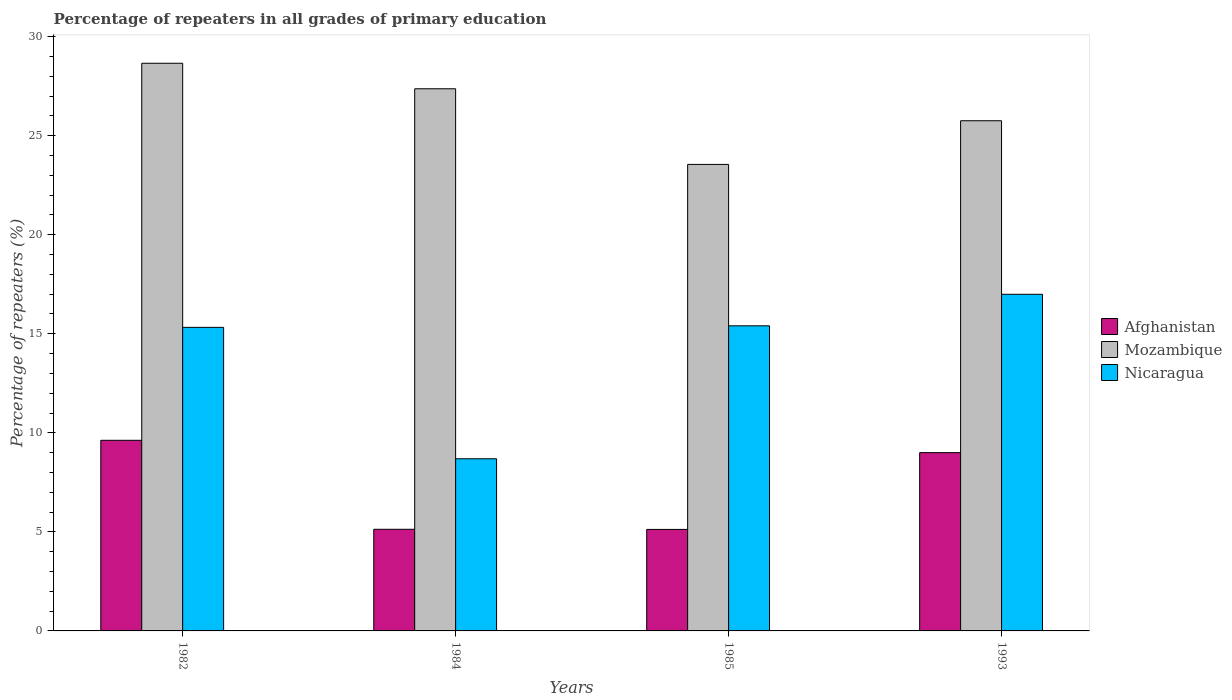How many groups of bars are there?
Keep it short and to the point. 4. Are the number of bars per tick equal to the number of legend labels?
Provide a short and direct response. Yes. How many bars are there on the 4th tick from the left?
Offer a very short reply. 3. How many bars are there on the 4th tick from the right?
Offer a terse response. 3. What is the label of the 2nd group of bars from the left?
Give a very brief answer. 1984. What is the percentage of repeaters in Nicaragua in 1993?
Make the answer very short. 16.99. Across all years, what is the maximum percentage of repeaters in Afghanistan?
Ensure brevity in your answer.  9.62. Across all years, what is the minimum percentage of repeaters in Nicaragua?
Offer a terse response. 8.69. In which year was the percentage of repeaters in Mozambique maximum?
Give a very brief answer. 1982. In which year was the percentage of repeaters in Afghanistan minimum?
Provide a succinct answer. 1985. What is the total percentage of repeaters in Nicaragua in the graph?
Offer a very short reply. 56.41. What is the difference between the percentage of repeaters in Afghanistan in 1984 and that in 1985?
Make the answer very short. 0.01. What is the difference between the percentage of repeaters in Mozambique in 1985 and the percentage of repeaters in Afghanistan in 1984?
Your response must be concise. 18.42. What is the average percentage of repeaters in Mozambique per year?
Your response must be concise. 26.33. In the year 1985, what is the difference between the percentage of repeaters in Nicaragua and percentage of repeaters in Afghanistan?
Offer a very short reply. 10.28. What is the ratio of the percentage of repeaters in Mozambique in 1982 to that in 1984?
Offer a terse response. 1.05. Is the percentage of repeaters in Mozambique in 1982 less than that in 1984?
Your answer should be very brief. No. What is the difference between the highest and the second highest percentage of repeaters in Nicaragua?
Provide a succinct answer. 1.59. What is the difference between the highest and the lowest percentage of repeaters in Mozambique?
Keep it short and to the point. 5.11. In how many years, is the percentage of repeaters in Afghanistan greater than the average percentage of repeaters in Afghanistan taken over all years?
Provide a short and direct response. 2. Is the sum of the percentage of repeaters in Afghanistan in 1985 and 1993 greater than the maximum percentage of repeaters in Mozambique across all years?
Your answer should be very brief. No. What does the 2nd bar from the left in 1993 represents?
Offer a very short reply. Mozambique. What does the 2nd bar from the right in 1993 represents?
Provide a short and direct response. Mozambique. Is it the case that in every year, the sum of the percentage of repeaters in Nicaragua and percentage of repeaters in Afghanistan is greater than the percentage of repeaters in Mozambique?
Offer a terse response. No. How many bars are there?
Give a very brief answer. 12. Are all the bars in the graph horizontal?
Make the answer very short. No. How many years are there in the graph?
Offer a very short reply. 4. What is the difference between two consecutive major ticks on the Y-axis?
Your answer should be very brief. 5. Are the values on the major ticks of Y-axis written in scientific E-notation?
Your response must be concise. No. Does the graph contain any zero values?
Offer a terse response. No. Where does the legend appear in the graph?
Your response must be concise. Center right. How many legend labels are there?
Your answer should be very brief. 3. What is the title of the graph?
Your response must be concise. Percentage of repeaters in all grades of primary education. What is the label or title of the X-axis?
Ensure brevity in your answer.  Years. What is the label or title of the Y-axis?
Offer a very short reply. Percentage of repeaters (%). What is the Percentage of repeaters (%) of Afghanistan in 1982?
Offer a terse response. 9.62. What is the Percentage of repeaters (%) in Mozambique in 1982?
Your response must be concise. 28.65. What is the Percentage of repeaters (%) in Nicaragua in 1982?
Ensure brevity in your answer.  15.32. What is the Percentage of repeaters (%) of Afghanistan in 1984?
Provide a short and direct response. 5.13. What is the Percentage of repeaters (%) of Mozambique in 1984?
Make the answer very short. 27.37. What is the Percentage of repeaters (%) in Nicaragua in 1984?
Keep it short and to the point. 8.69. What is the Percentage of repeaters (%) in Afghanistan in 1985?
Your response must be concise. 5.12. What is the Percentage of repeaters (%) in Mozambique in 1985?
Make the answer very short. 23.55. What is the Percentage of repeaters (%) of Nicaragua in 1985?
Offer a very short reply. 15.4. What is the Percentage of repeaters (%) of Afghanistan in 1993?
Offer a terse response. 9. What is the Percentage of repeaters (%) of Mozambique in 1993?
Offer a very short reply. 25.75. What is the Percentage of repeaters (%) in Nicaragua in 1993?
Offer a terse response. 16.99. Across all years, what is the maximum Percentage of repeaters (%) in Afghanistan?
Keep it short and to the point. 9.62. Across all years, what is the maximum Percentage of repeaters (%) in Mozambique?
Your answer should be compact. 28.65. Across all years, what is the maximum Percentage of repeaters (%) of Nicaragua?
Provide a short and direct response. 16.99. Across all years, what is the minimum Percentage of repeaters (%) of Afghanistan?
Your answer should be very brief. 5.12. Across all years, what is the minimum Percentage of repeaters (%) of Mozambique?
Your response must be concise. 23.55. Across all years, what is the minimum Percentage of repeaters (%) in Nicaragua?
Give a very brief answer. 8.69. What is the total Percentage of repeaters (%) in Afghanistan in the graph?
Ensure brevity in your answer.  28.88. What is the total Percentage of repeaters (%) in Mozambique in the graph?
Your answer should be compact. 105.32. What is the total Percentage of repeaters (%) in Nicaragua in the graph?
Keep it short and to the point. 56.41. What is the difference between the Percentage of repeaters (%) in Afghanistan in 1982 and that in 1984?
Your answer should be compact. 4.49. What is the difference between the Percentage of repeaters (%) in Mozambique in 1982 and that in 1984?
Keep it short and to the point. 1.29. What is the difference between the Percentage of repeaters (%) of Nicaragua in 1982 and that in 1984?
Give a very brief answer. 6.63. What is the difference between the Percentage of repeaters (%) in Afghanistan in 1982 and that in 1985?
Your answer should be very brief. 4.5. What is the difference between the Percentage of repeaters (%) of Mozambique in 1982 and that in 1985?
Provide a succinct answer. 5.11. What is the difference between the Percentage of repeaters (%) in Nicaragua in 1982 and that in 1985?
Your answer should be very brief. -0.08. What is the difference between the Percentage of repeaters (%) of Afghanistan in 1982 and that in 1993?
Keep it short and to the point. 0.62. What is the difference between the Percentage of repeaters (%) in Mozambique in 1982 and that in 1993?
Your answer should be compact. 2.9. What is the difference between the Percentage of repeaters (%) in Nicaragua in 1982 and that in 1993?
Provide a short and direct response. -1.67. What is the difference between the Percentage of repeaters (%) of Afghanistan in 1984 and that in 1985?
Provide a succinct answer. 0.01. What is the difference between the Percentage of repeaters (%) of Mozambique in 1984 and that in 1985?
Offer a terse response. 3.82. What is the difference between the Percentage of repeaters (%) in Nicaragua in 1984 and that in 1985?
Ensure brevity in your answer.  -6.71. What is the difference between the Percentage of repeaters (%) in Afghanistan in 1984 and that in 1993?
Offer a terse response. -3.87. What is the difference between the Percentage of repeaters (%) of Mozambique in 1984 and that in 1993?
Offer a very short reply. 1.61. What is the difference between the Percentage of repeaters (%) in Nicaragua in 1984 and that in 1993?
Your response must be concise. -8.3. What is the difference between the Percentage of repeaters (%) of Afghanistan in 1985 and that in 1993?
Make the answer very short. -3.88. What is the difference between the Percentage of repeaters (%) of Mozambique in 1985 and that in 1993?
Make the answer very short. -2.2. What is the difference between the Percentage of repeaters (%) of Nicaragua in 1985 and that in 1993?
Your response must be concise. -1.59. What is the difference between the Percentage of repeaters (%) in Afghanistan in 1982 and the Percentage of repeaters (%) in Mozambique in 1984?
Keep it short and to the point. -17.74. What is the difference between the Percentage of repeaters (%) of Afghanistan in 1982 and the Percentage of repeaters (%) of Nicaragua in 1984?
Provide a short and direct response. 0.93. What is the difference between the Percentage of repeaters (%) in Mozambique in 1982 and the Percentage of repeaters (%) in Nicaragua in 1984?
Keep it short and to the point. 19.96. What is the difference between the Percentage of repeaters (%) in Afghanistan in 1982 and the Percentage of repeaters (%) in Mozambique in 1985?
Your response must be concise. -13.93. What is the difference between the Percentage of repeaters (%) in Afghanistan in 1982 and the Percentage of repeaters (%) in Nicaragua in 1985?
Your answer should be very brief. -5.78. What is the difference between the Percentage of repeaters (%) in Mozambique in 1982 and the Percentage of repeaters (%) in Nicaragua in 1985?
Your answer should be compact. 13.25. What is the difference between the Percentage of repeaters (%) of Afghanistan in 1982 and the Percentage of repeaters (%) of Mozambique in 1993?
Your response must be concise. -16.13. What is the difference between the Percentage of repeaters (%) of Afghanistan in 1982 and the Percentage of repeaters (%) of Nicaragua in 1993?
Your response must be concise. -7.37. What is the difference between the Percentage of repeaters (%) in Mozambique in 1982 and the Percentage of repeaters (%) in Nicaragua in 1993?
Make the answer very short. 11.66. What is the difference between the Percentage of repeaters (%) of Afghanistan in 1984 and the Percentage of repeaters (%) of Mozambique in 1985?
Make the answer very short. -18.42. What is the difference between the Percentage of repeaters (%) in Afghanistan in 1984 and the Percentage of repeaters (%) in Nicaragua in 1985?
Offer a very short reply. -10.27. What is the difference between the Percentage of repeaters (%) of Mozambique in 1984 and the Percentage of repeaters (%) of Nicaragua in 1985?
Give a very brief answer. 11.97. What is the difference between the Percentage of repeaters (%) in Afghanistan in 1984 and the Percentage of repeaters (%) in Mozambique in 1993?
Your answer should be compact. -20.62. What is the difference between the Percentage of repeaters (%) of Afghanistan in 1984 and the Percentage of repeaters (%) of Nicaragua in 1993?
Provide a succinct answer. -11.86. What is the difference between the Percentage of repeaters (%) of Mozambique in 1984 and the Percentage of repeaters (%) of Nicaragua in 1993?
Provide a short and direct response. 10.37. What is the difference between the Percentage of repeaters (%) of Afghanistan in 1985 and the Percentage of repeaters (%) of Mozambique in 1993?
Ensure brevity in your answer.  -20.63. What is the difference between the Percentage of repeaters (%) of Afghanistan in 1985 and the Percentage of repeaters (%) of Nicaragua in 1993?
Offer a very short reply. -11.87. What is the difference between the Percentage of repeaters (%) of Mozambique in 1985 and the Percentage of repeaters (%) of Nicaragua in 1993?
Provide a short and direct response. 6.56. What is the average Percentage of repeaters (%) in Afghanistan per year?
Keep it short and to the point. 7.22. What is the average Percentage of repeaters (%) of Mozambique per year?
Keep it short and to the point. 26.33. What is the average Percentage of repeaters (%) in Nicaragua per year?
Ensure brevity in your answer.  14.1. In the year 1982, what is the difference between the Percentage of repeaters (%) of Afghanistan and Percentage of repeaters (%) of Mozambique?
Your answer should be very brief. -19.03. In the year 1982, what is the difference between the Percentage of repeaters (%) of Afghanistan and Percentage of repeaters (%) of Nicaragua?
Offer a very short reply. -5.7. In the year 1982, what is the difference between the Percentage of repeaters (%) in Mozambique and Percentage of repeaters (%) in Nicaragua?
Provide a short and direct response. 13.33. In the year 1984, what is the difference between the Percentage of repeaters (%) of Afghanistan and Percentage of repeaters (%) of Mozambique?
Offer a terse response. -22.24. In the year 1984, what is the difference between the Percentage of repeaters (%) of Afghanistan and Percentage of repeaters (%) of Nicaragua?
Provide a short and direct response. -3.56. In the year 1984, what is the difference between the Percentage of repeaters (%) in Mozambique and Percentage of repeaters (%) in Nicaragua?
Keep it short and to the point. 18.68. In the year 1985, what is the difference between the Percentage of repeaters (%) in Afghanistan and Percentage of repeaters (%) in Mozambique?
Your answer should be compact. -18.42. In the year 1985, what is the difference between the Percentage of repeaters (%) of Afghanistan and Percentage of repeaters (%) of Nicaragua?
Your answer should be very brief. -10.28. In the year 1985, what is the difference between the Percentage of repeaters (%) of Mozambique and Percentage of repeaters (%) of Nicaragua?
Your answer should be very brief. 8.15. In the year 1993, what is the difference between the Percentage of repeaters (%) of Afghanistan and Percentage of repeaters (%) of Mozambique?
Give a very brief answer. -16.75. In the year 1993, what is the difference between the Percentage of repeaters (%) of Afghanistan and Percentage of repeaters (%) of Nicaragua?
Offer a terse response. -7.99. In the year 1993, what is the difference between the Percentage of repeaters (%) in Mozambique and Percentage of repeaters (%) in Nicaragua?
Offer a terse response. 8.76. What is the ratio of the Percentage of repeaters (%) in Afghanistan in 1982 to that in 1984?
Your response must be concise. 1.88. What is the ratio of the Percentage of repeaters (%) of Mozambique in 1982 to that in 1984?
Your answer should be very brief. 1.05. What is the ratio of the Percentage of repeaters (%) of Nicaragua in 1982 to that in 1984?
Your answer should be compact. 1.76. What is the ratio of the Percentage of repeaters (%) in Afghanistan in 1982 to that in 1985?
Keep it short and to the point. 1.88. What is the ratio of the Percentage of repeaters (%) of Mozambique in 1982 to that in 1985?
Keep it short and to the point. 1.22. What is the ratio of the Percentage of repeaters (%) in Nicaragua in 1982 to that in 1985?
Your response must be concise. 0.99. What is the ratio of the Percentage of repeaters (%) in Afghanistan in 1982 to that in 1993?
Offer a very short reply. 1.07. What is the ratio of the Percentage of repeaters (%) of Mozambique in 1982 to that in 1993?
Provide a short and direct response. 1.11. What is the ratio of the Percentage of repeaters (%) in Nicaragua in 1982 to that in 1993?
Your answer should be compact. 0.9. What is the ratio of the Percentage of repeaters (%) of Afghanistan in 1984 to that in 1985?
Your response must be concise. 1. What is the ratio of the Percentage of repeaters (%) in Mozambique in 1984 to that in 1985?
Give a very brief answer. 1.16. What is the ratio of the Percentage of repeaters (%) of Nicaragua in 1984 to that in 1985?
Give a very brief answer. 0.56. What is the ratio of the Percentage of repeaters (%) in Afghanistan in 1984 to that in 1993?
Keep it short and to the point. 0.57. What is the ratio of the Percentage of repeaters (%) of Mozambique in 1984 to that in 1993?
Your answer should be compact. 1.06. What is the ratio of the Percentage of repeaters (%) of Nicaragua in 1984 to that in 1993?
Provide a short and direct response. 0.51. What is the ratio of the Percentage of repeaters (%) of Afghanistan in 1985 to that in 1993?
Your response must be concise. 0.57. What is the ratio of the Percentage of repeaters (%) of Mozambique in 1985 to that in 1993?
Offer a very short reply. 0.91. What is the ratio of the Percentage of repeaters (%) in Nicaragua in 1985 to that in 1993?
Provide a short and direct response. 0.91. What is the difference between the highest and the second highest Percentage of repeaters (%) of Afghanistan?
Your answer should be very brief. 0.62. What is the difference between the highest and the second highest Percentage of repeaters (%) in Mozambique?
Make the answer very short. 1.29. What is the difference between the highest and the second highest Percentage of repeaters (%) in Nicaragua?
Offer a terse response. 1.59. What is the difference between the highest and the lowest Percentage of repeaters (%) in Afghanistan?
Make the answer very short. 4.5. What is the difference between the highest and the lowest Percentage of repeaters (%) of Mozambique?
Your answer should be compact. 5.11. What is the difference between the highest and the lowest Percentage of repeaters (%) in Nicaragua?
Ensure brevity in your answer.  8.3. 